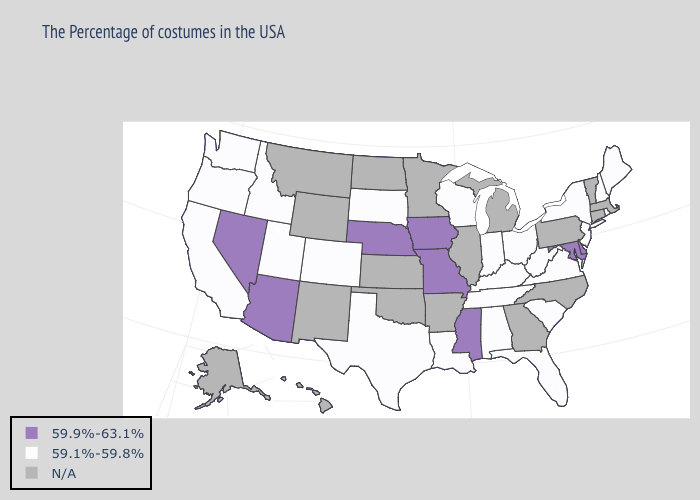What is the highest value in the USA?
Answer briefly. 59.9%-63.1%. How many symbols are there in the legend?
Answer briefly. 3. What is the value of Kansas?
Keep it brief. N/A. What is the value of Texas?
Answer briefly. 59.1%-59.8%. What is the value of Kansas?
Keep it brief. N/A. What is the lowest value in the USA?
Answer briefly. 59.1%-59.8%. What is the highest value in states that border Colorado?
Quick response, please. 59.9%-63.1%. Does Arizona have the highest value in the West?
Give a very brief answer. Yes. What is the highest value in the USA?
Concise answer only. 59.9%-63.1%. How many symbols are there in the legend?
Keep it brief. 3. What is the lowest value in the South?
Quick response, please. 59.1%-59.8%. Does Arizona have the lowest value in the West?
Be succinct. No. 